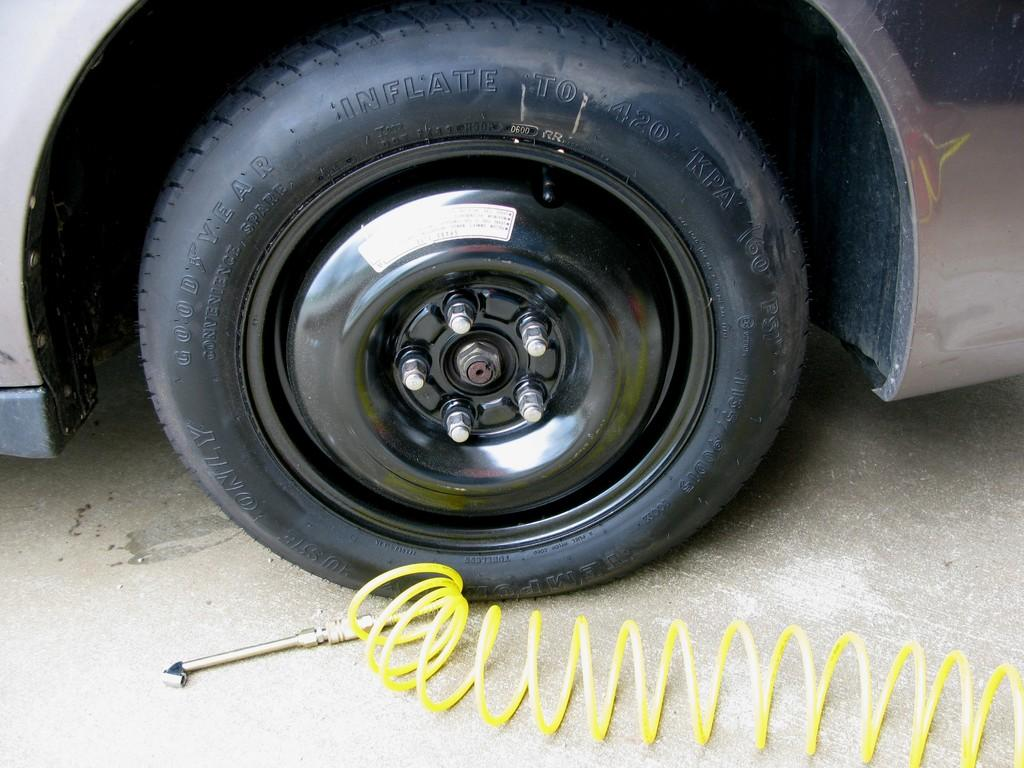What is the main subject of the image? There is a vehicle in the image. What object can be seen at the bottom of the image? There is a tool at the bottom of the image. Can you describe another object in the image? There is a spring in the image. How does the vehicle attack the spring in the image? There is no attack or interaction between the vehicle and the spring in the image; they are separate objects. 